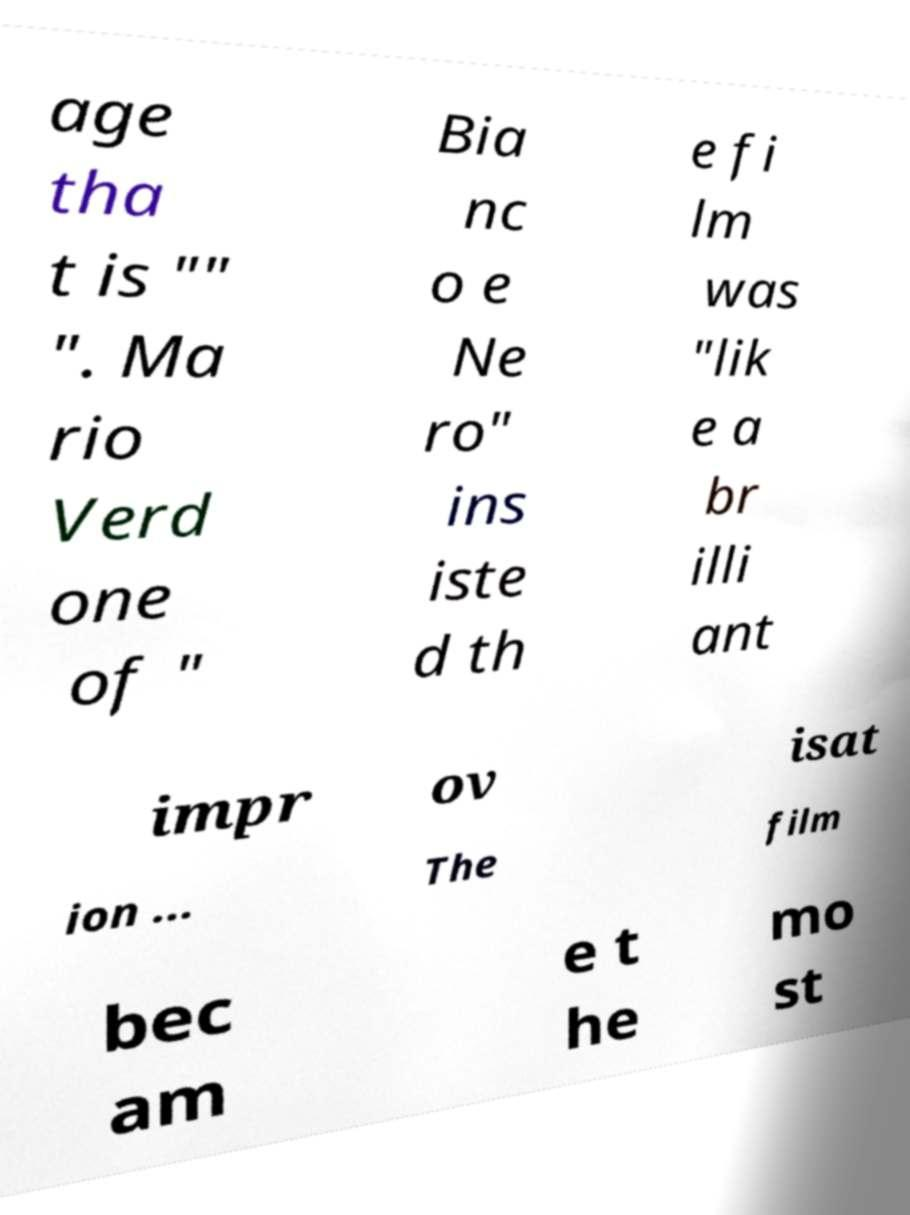Please read and relay the text visible in this image. What does it say? age tha t is "" ". Ma rio Verd one of " Bia nc o e Ne ro" ins iste d th e fi lm was "lik e a br illi ant impr ov isat ion ... The film bec am e t he mo st 